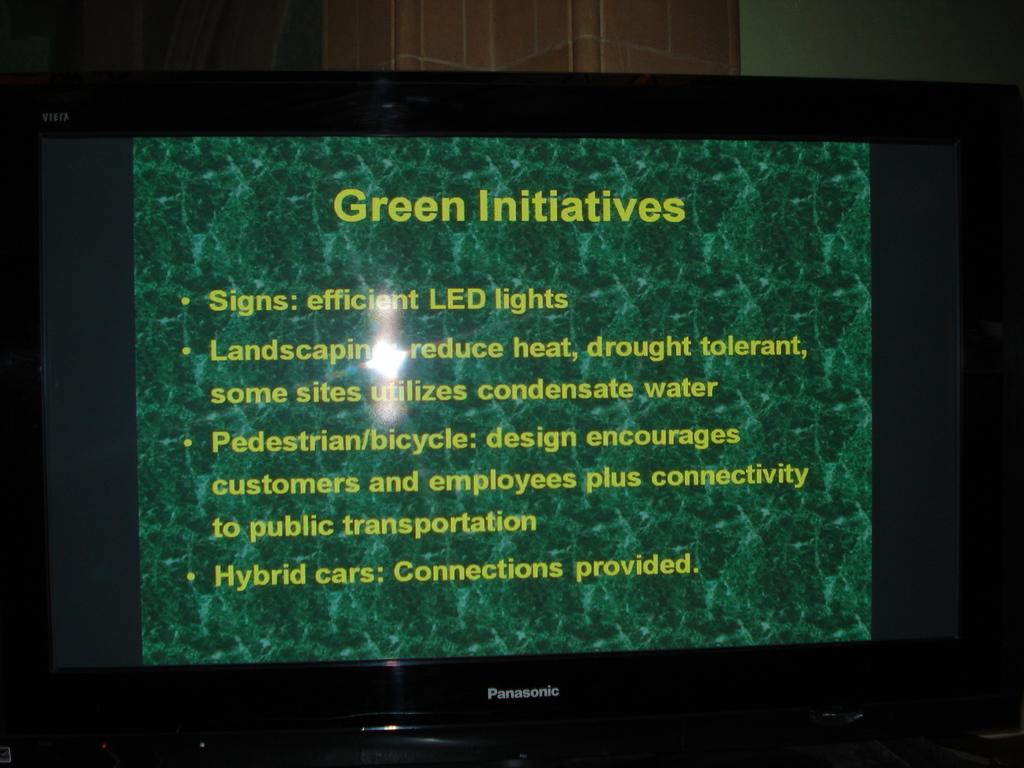What is the main object in the image? There is a TV screen in the image. What is displayed on the TV screen? The TV screen displays a poster. What message is conveyed by the poster? The poster has the text "Green Initiative" on it. How many bridges can be seen in the image? There are no bridges present in the image. What is the angle of the land in the image? There is no land visible in the image, as it only features a TV screen displaying a poster. 